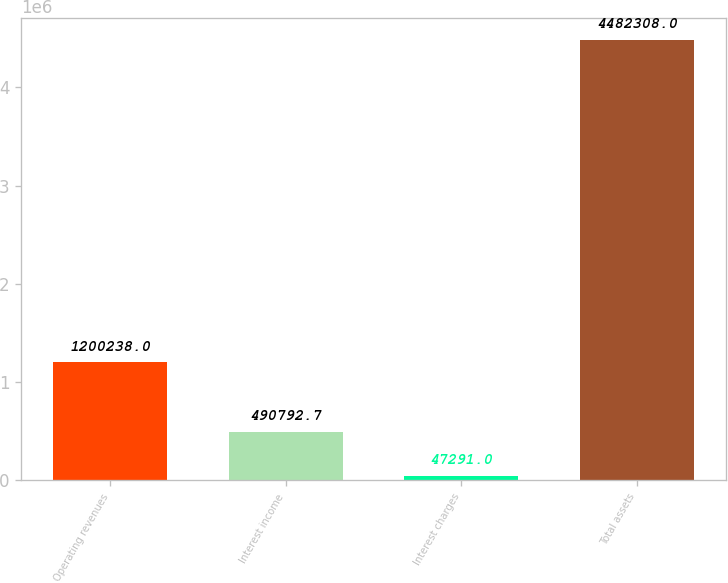Convert chart to OTSL. <chart><loc_0><loc_0><loc_500><loc_500><bar_chart><fcel>Operating revenues<fcel>Interest income<fcel>Interest charges<fcel>Total assets<nl><fcel>1.20024e+06<fcel>490793<fcel>47291<fcel>4.48231e+06<nl></chart> 